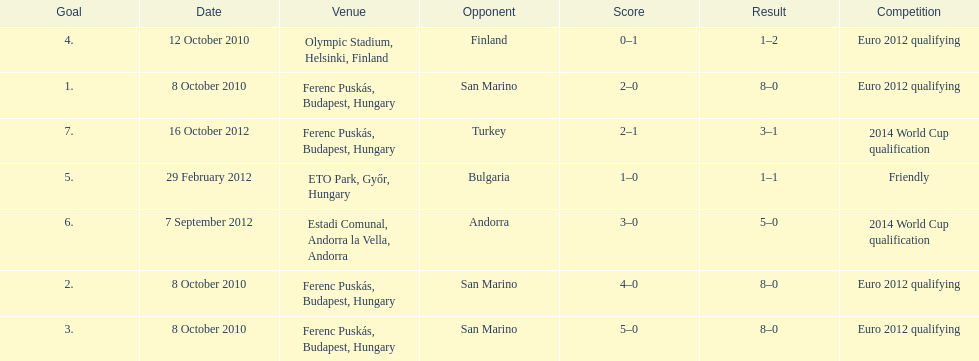What is the number of goals ádám szalai made against san marino in 2010? 3. 